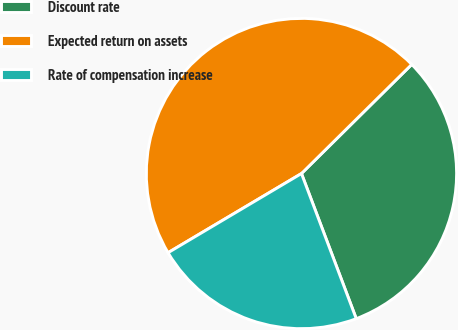<chart> <loc_0><loc_0><loc_500><loc_500><pie_chart><fcel>Discount rate<fcel>Expected return on assets<fcel>Rate of compensation increase<nl><fcel>31.67%<fcel>46.11%<fcel>22.22%<nl></chart> 